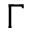Convert formula to latex. <formula><loc_0><loc_0><loc_500><loc_500>\Gamma</formula> 